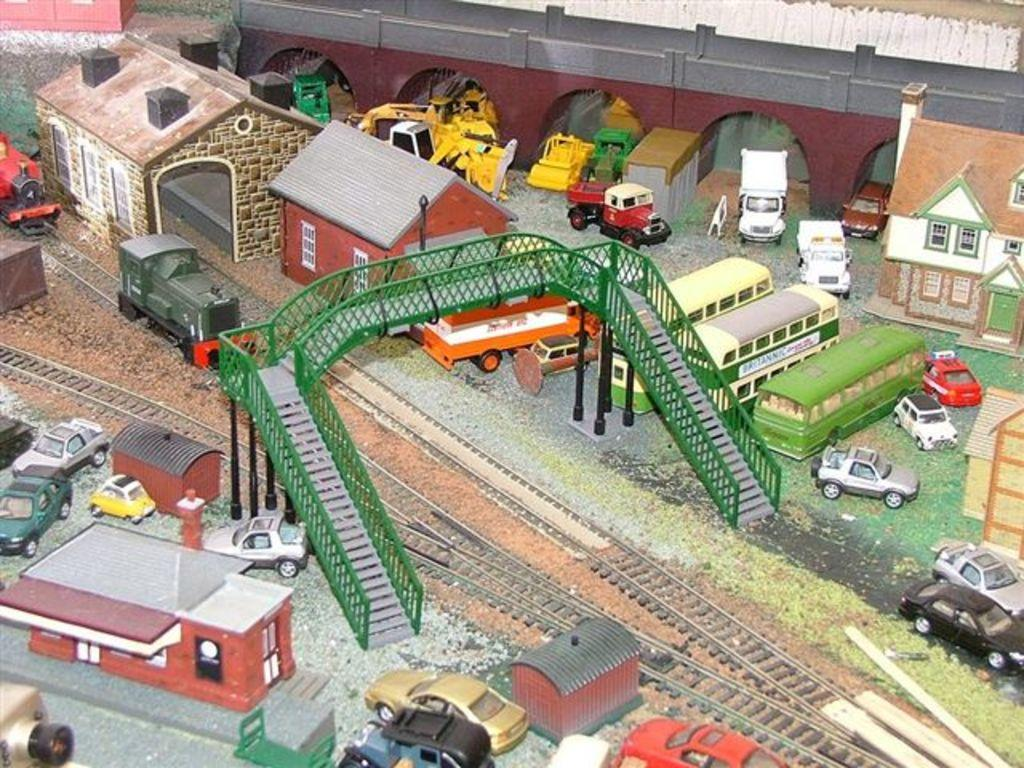What type of toys are present in the image? There are toys of buildings, vehicles, a bridge, and a train in the image. What is the toy train placed on in the image? The toy train is placed on a toy track in the image. What can be seen beneath the toys in the image? The ground is visible in the image. Can you tell me what type of argument is taking place between the toy buildings in the image? There is no argument taking place between the toy buildings in the image, as they are inanimate objects and cannot engage in arguments. 